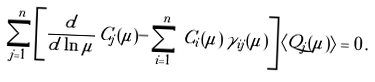Convert formula to latex. <formula><loc_0><loc_0><loc_500><loc_500>\sum _ { j = 1 } ^ { n } \left [ \frac { d } { d \ln \mu } \, C _ { j } ( \mu ) - \sum _ { i = 1 } ^ { n } \, C _ { i } ( \mu ) \, \gamma _ { i j } ( \mu ) \right ] \langle Q _ { j } ( \mu ) \rangle = 0 \, .</formula> 